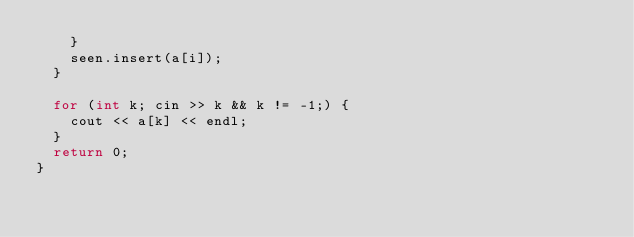<code> <loc_0><loc_0><loc_500><loc_500><_C++_>    }
    seen.insert(a[i]);
  }

  for (int k; cin >> k && k != -1;) {
    cout << a[k] << endl;
  }
  return 0;
}</code> 